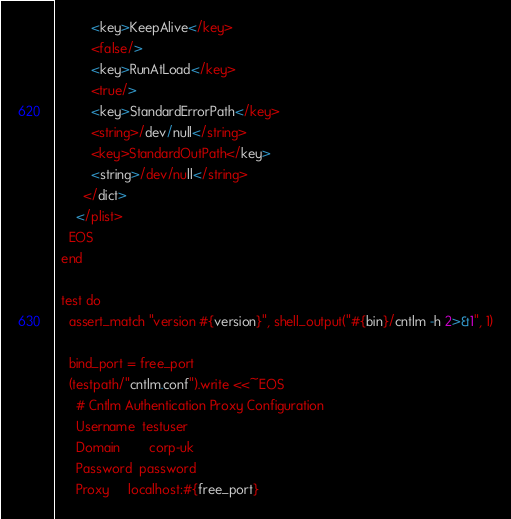Convert code to text. <code><loc_0><loc_0><loc_500><loc_500><_Ruby_>          <key>KeepAlive</key>
          <false/>
          <key>RunAtLoad</key>
          <true/>
          <key>StandardErrorPath</key>
          <string>/dev/null</string>
          <key>StandardOutPath</key>
          <string>/dev/null</string>
        </dict>
      </plist>
    EOS
  end

  test do
    assert_match "version #{version}", shell_output("#{bin}/cntlm -h 2>&1", 1)

    bind_port = free_port
    (testpath/"cntlm.conf").write <<~EOS
      # Cntlm Authentication Proxy Configuration
      Username	testuser
      Domain		corp-uk
      Password	password
      Proxy		localhost:#{free_port}</code> 